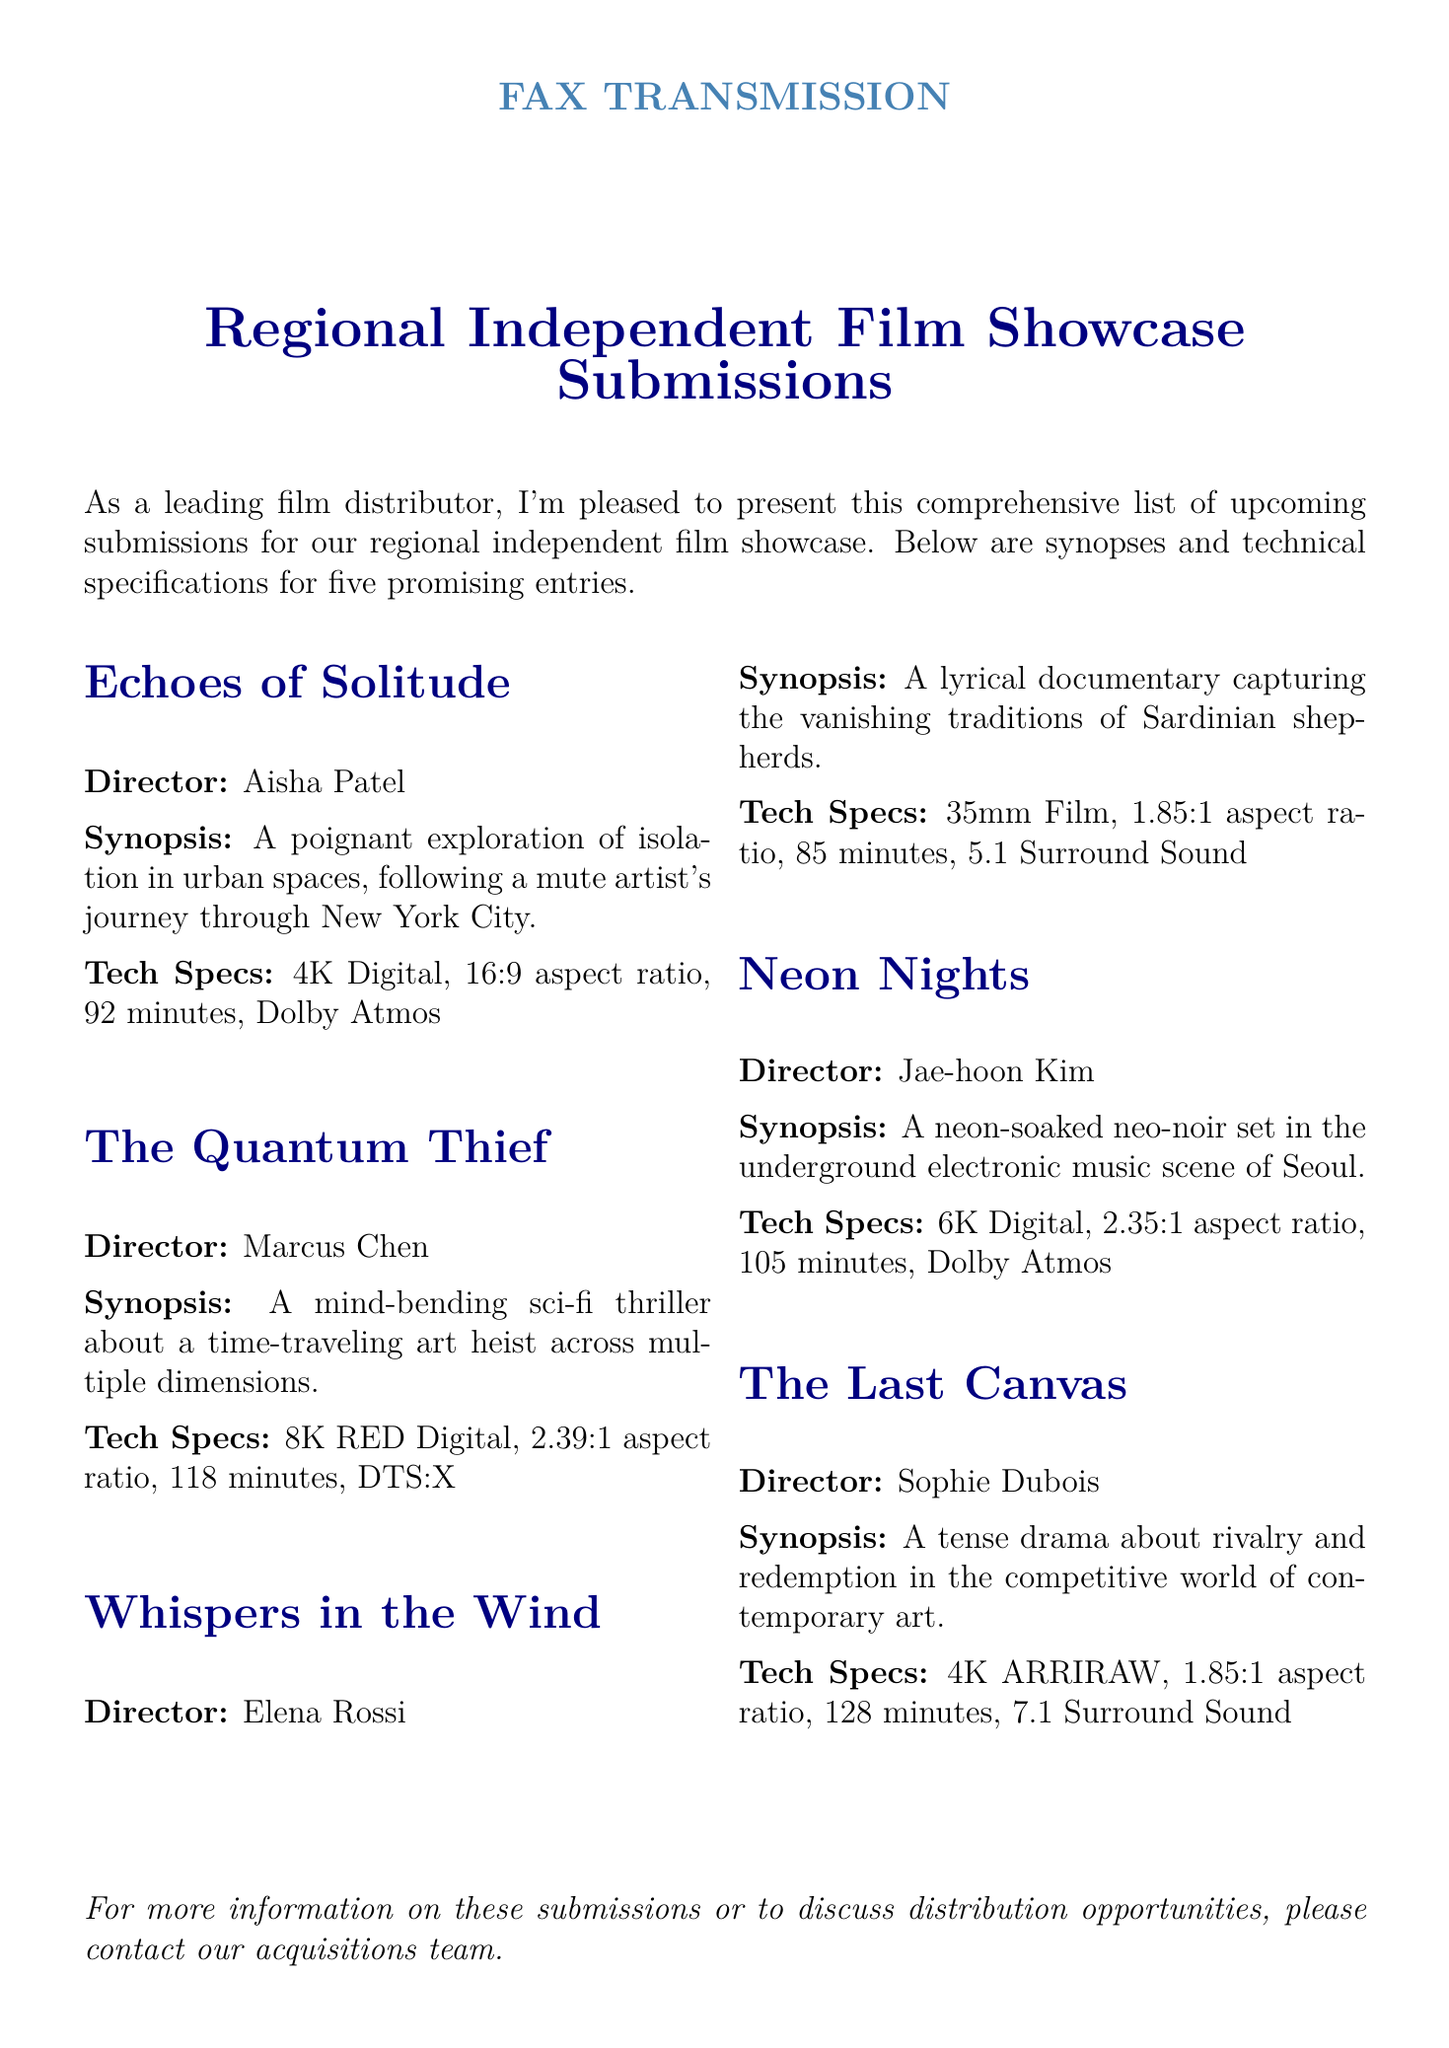What is the title of the first film listed? The title of the first film listed in the document is "Echoes of Solitude."
Answer: Echoes of Solitude Who is the director of "The Quantum Thief"? The director of "The Quantum Thief" is Marcus Chen.
Answer: Marcus Chen What is the aspect ratio of "Whispers in the Wind"? The aspect ratio for "Whispers in the Wind" is 1.85:1.
Answer: 1.85:1 How long is "Neon Nights"? The duration of "Neon Nights" is 105 minutes.
Answer: 105 minutes Which film has the highest resolution in the submissions? "The Quantum Thief" has the highest resolution at 8K RED Digital.
Answer: 8K RED Digital What theme does "Echoes of Solitude" explore? "Echoes of Solitude" explores the theme of isolation in urban spaces.
Answer: Isolation in urban spaces What type of sound format is used in "The Last Canvas"? "The Last Canvas" uses 7.1 Surround Sound.
Answer: 7.1 Surround Sound How many submissions are listed in the document? The document lists a total of five submissions.
Answer: Five submissions Which film is described as a "lyrical documentary"? The film described as a "lyrical documentary" is "Whispers in the Wind."
Answer: Whispers in the Wind 